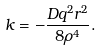Convert formula to latex. <formula><loc_0><loc_0><loc_500><loc_500>k = - \frac { D q ^ { 2 } r ^ { 2 } } { 8 \rho ^ { 4 } } .</formula> 